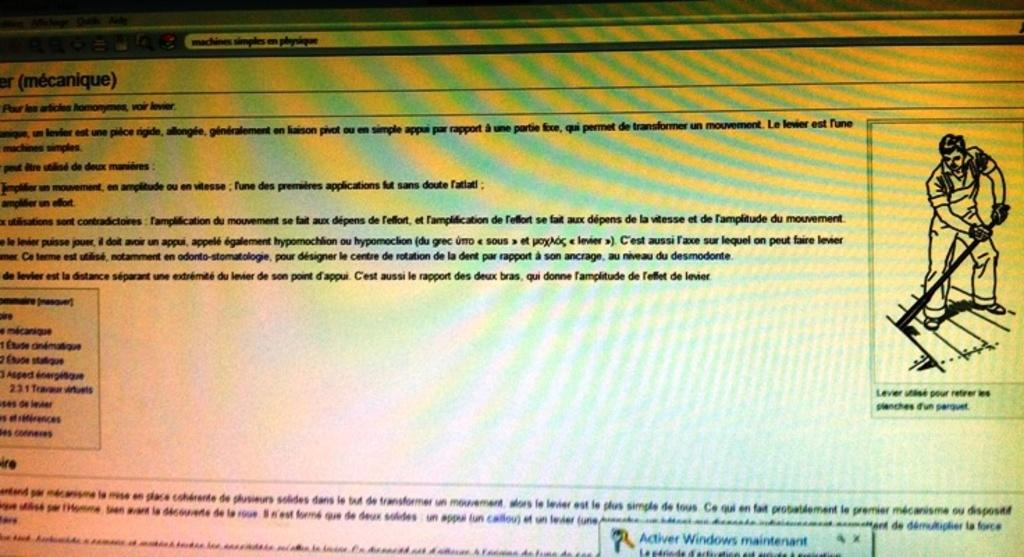What is present in the image alongside the text? There is an image of a person in the image. How can the text be described in terms of its appearance? The text has colorful designs. How many fingers can be seen on the person in the image? There is no information about the person's fingers in the image, as the focus is on the text and its colorful designs. 